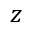<formula> <loc_0><loc_0><loc_500><loc_500>z</formula> 